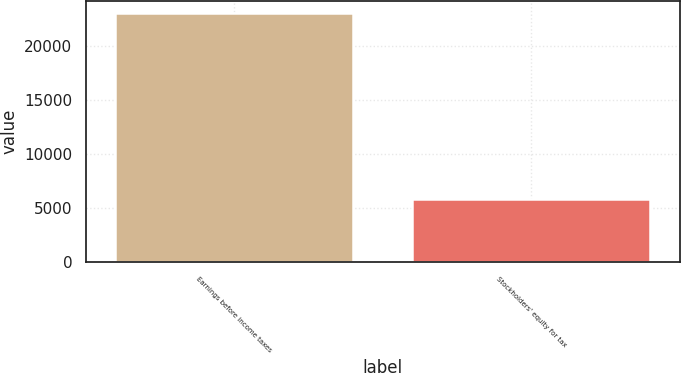Convert chart to OTSL. <chart><loc_0><loc_0><loc_500><loc_500><bar_chart><fcel>Earnings before income taxes<fcel>Stockholders' equity for tax<nl><fcel>23031<fcel>5823<nl></chart> 